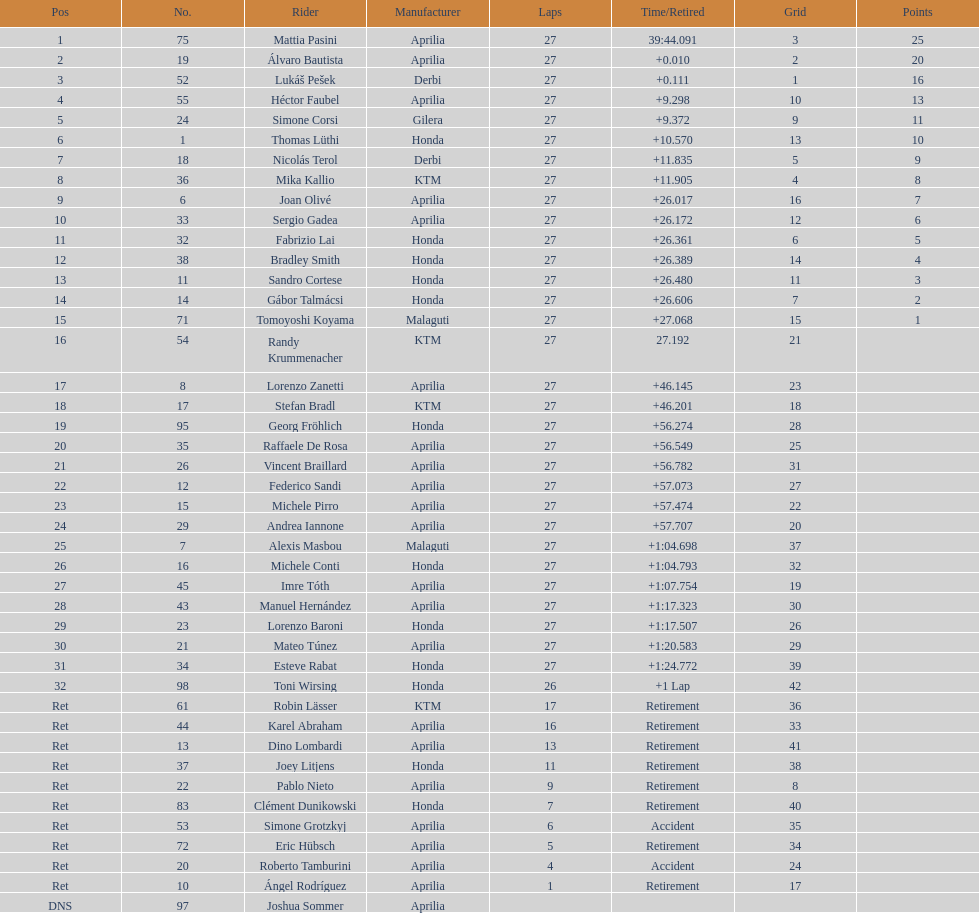How many german racers completed the race? 4. Parse the full table. {'header': ['Pos', 'No.', 'Rider', 'Manufacturer', 'Laps', 'Time/Retired', 'Grid', 'Points'], 'rows': [['1', '75', 'Mattia Pasini', 'Aprilia', '27', '39:44.091', '3', '25'], ['2', '19', 'Álvaro Bautista', 'Aprilia', '27', '+0.010', '2', '20'], ['3', '52', 'Lukáš Pešek', 'Derbi', '27', '+0.111', '1', '16'], ['4', '55', 'Héctor Faubel', 'Aprilia', '27', '+9.298', '10', '13'], ['5', '24', 'Simone Corsi', 'Gilera', '27', '+9.372', '9', '11'], ['6', '1', 'Thomas Lüthi', 'Honda', '27', '+10.570', '13', '10'], ['7', '18', 'Nicolás Terol', 'Derbi', '27', '+11.835', '5', '9'], ['8', '36', 'Mika Kallio', 'KTM', '27', '+11.905', '4', '8'], ['9', '6', 'Joan Olivé', 'Aprilia', '27', '+26.017', '16', '7'], ['10', '33', 'Sergio Gadea', 'Aprilia', '27', '+26.172', '12', '6'], ['11', '32', 'Fabrizio Lai', 'Honda', '27', '+26.361', '6', '5'], ['12', '38', 'Bradley Smith', 'Honda', '27', '+26.389', '14', '4'], ['13', '11', 'Sandro Cortese', 'Honda', '27', '+26.480', '11', '3'], ['14', '14', 'Gábor Talmácsi', 'Honda', '27', '+26.606', '7', '2'], ['15', '71', 'Tomoyoshi Koyama', 'Malaguti', '27', '+27.068', '15', '1'], ['16', '54', 'Randy Krummenacher', 'KTM', '27', '27.192', '21', ''], ['17', '8', 'Lorenzo Zanetti', 'Aprilia', '27', '+46.145', '23', ''], ['18', '17', 'Stefan Bradl', 'KTM', '27', '+46.201', '18', ''], ['19', '95', 'Georg Fröhlich', 'Honda', '27', '+56.274', '28', ''], ['20', '35', 'Raffaele De Rosa', 'Aprilia', '27', '+56.549', '25', ''], ['21', '26', 'Vincent Braillard', 'Aprilia', '27', '+56.782', '31', ''], ['22', '12', 'Federico Sandi', 'Aprilia', '27', '+57.073', '27', ''], ['23', '15', 'Michele Pirro', 'Aprilia', '27', '+57.474', '22', ''], ['24', '29', 'Andrea Iannone', 'Aprilia', '27', '+57.707', '20', ''], ['25', '7', 'Alexis Masbou', 'Malaguti', '27', '+1:04.698', '37', ''], ['26', '16', 'Michele Conti', 'Honda', '27', '+1:04.793', '32', ''], ['27', '45', 'Imre Tóth', 'Aprilia', '27', '+1:07.754', '19', ''], ['28', '43', 'Manuel Hernández', 'Aprilia', '27', '+1:17.323', '30', ''], ['29', '23', 'Lorenzo Baroni', 'Honda', '27', '+1:17.507', '26', ''], ['30', '21', 'Mateo Túnez', 'Aprilia', '27', '+1:20.583', '29', ''], ['31', '34', 'Esteve Rabat', 'Honda', '27', '+1:24.772', '39', ''], ['32', '98', 'Toni Wirsing', 'Honda', '26', '+1 Lap', '42', ''], ['Ret', '61', 'Robin Lässer', 'KTM', '17', 'Retirement', '36', ''], ['Ret', '44', 'Karel Abraham', 'Aprilia', '16', 'Retirement', '33', ''], ['Ret', '13', 'Dino Lombardi', 'Aprilia', '13', 'Retirement', '41', ''], ['Ret', '37', 'Joey Litjens', 'Honda', '11', 'Retirement', '38', ''], ['Ret', '22', 'Pablo Nieto', 'Aprilia', '9', 'Retirement', '8', ''], ['Ret', '83', 'Clément Dunikowski', 'Honda', '7', 'Retirement', '40', ''], ['Ret', '53', 'Simone Grotzkyj', 'Aprilia', '6', 'Accident', '35', ''], ['Ret', '72', 'Eric Hübsch', 'Aprilia', '5', 'Retirement', '34', ''], ['Ret', '20', 'Roberto Tamburini', 'Aprilia', '4', 'Accident', '24', ''], ['Ret', '10', 'Ángel Rodríguez', 'Aprilia', '1', 'Retirement', '17', ''], ['DNS', '97', 'Joshua Sommer', 'Aprilia', '', '', '', '']]} 